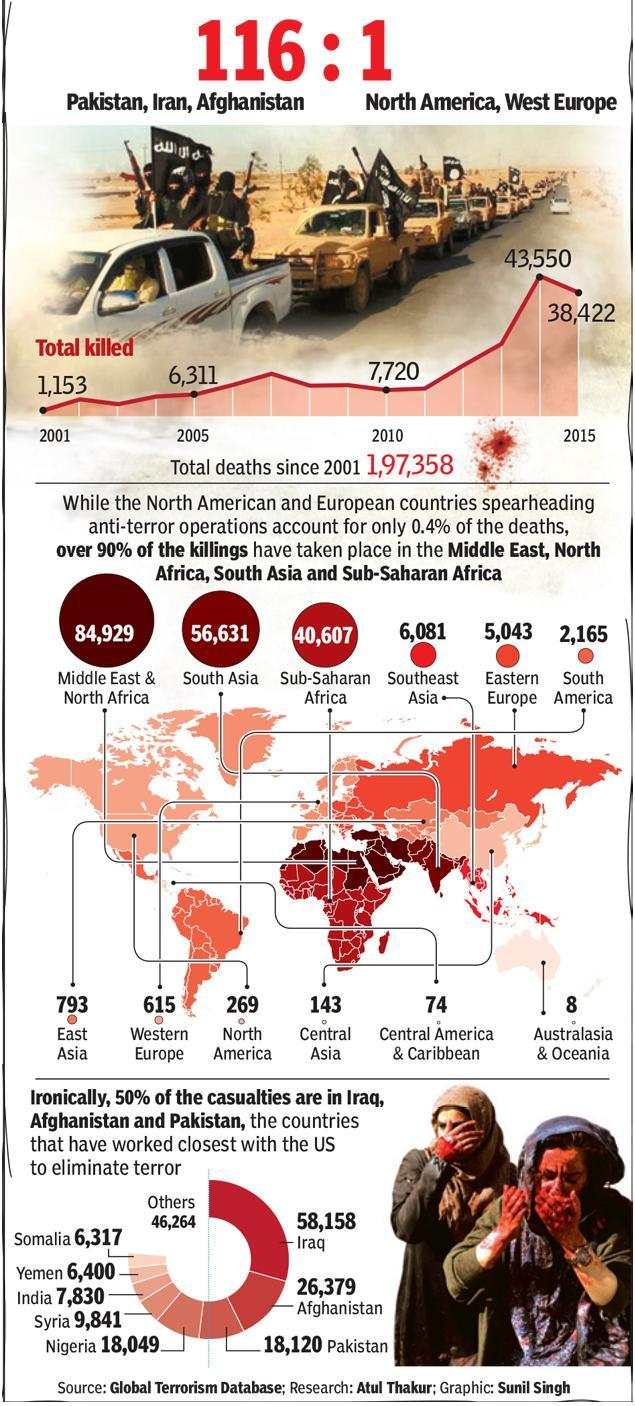What was the number of casualties in India?
Answer the question with a short phrase. 7,830 In which year was the total number of deaths the highest - 2013, 2014 or 2015? 2014 What was the number of casualties in Iraq? 58,158 How many "more"  casualties were there in Yemen when compared to Somalia? 83 Which are the countries that joined hands with the US to eliminate terrorism? Iraq, Afghanistan and Pakistan What was the total number of deaths in 2014? 43,550 What is the total number of deaths in the Middle East and North Africa? 84,929 What was the total number of deaths in South America and North America? 2434 Which country stood second in the number of casualties? Afghanistan In which year was the total number of deaths higher, in 2005 or in 2007? 2007 Which region has the least number of deaths? Australasia & Oceania How much more was the total number of deaths in 2014 when compared to 2015? 5128 What is the total number of deaths in South Asia? 56,631 Which region had a higher number of deaths - South America, East Asia or South Asia? South Asia What were the number of deaths in western Europe? 615 Which country had the highest number of casualties - Syria, Pakistan or India? Pakistan What was the total number of deaths in Western and Eastern Europe? 5658 